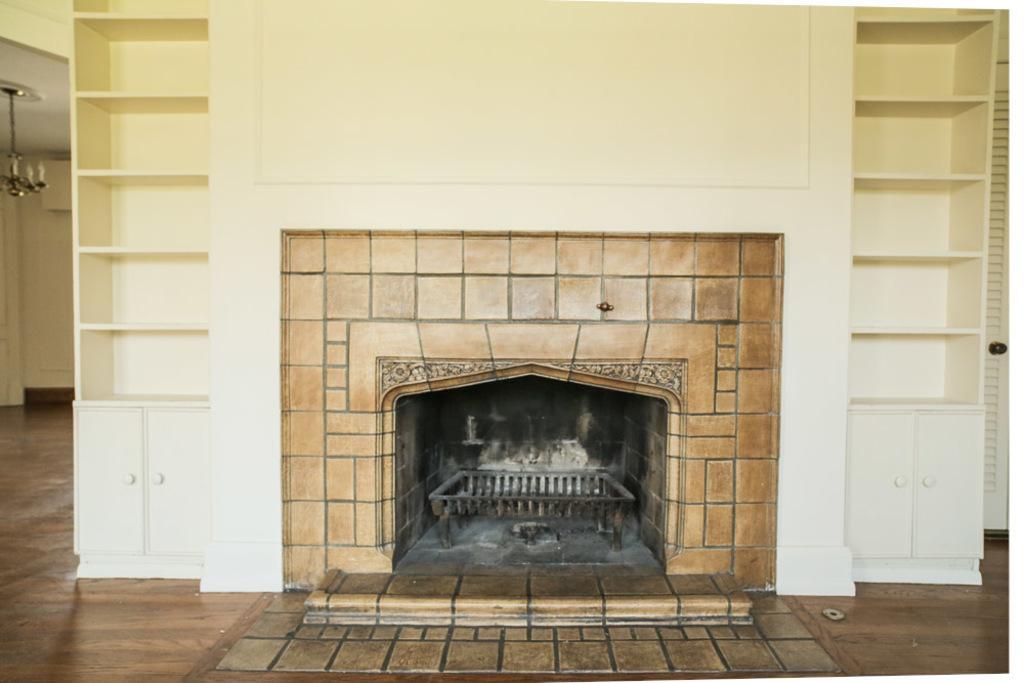Could you give a brief overview of what you see in this image? Here we can see a wooden oven and there are cupboards. This is wall and there is a ceiling light. And this is floor. 